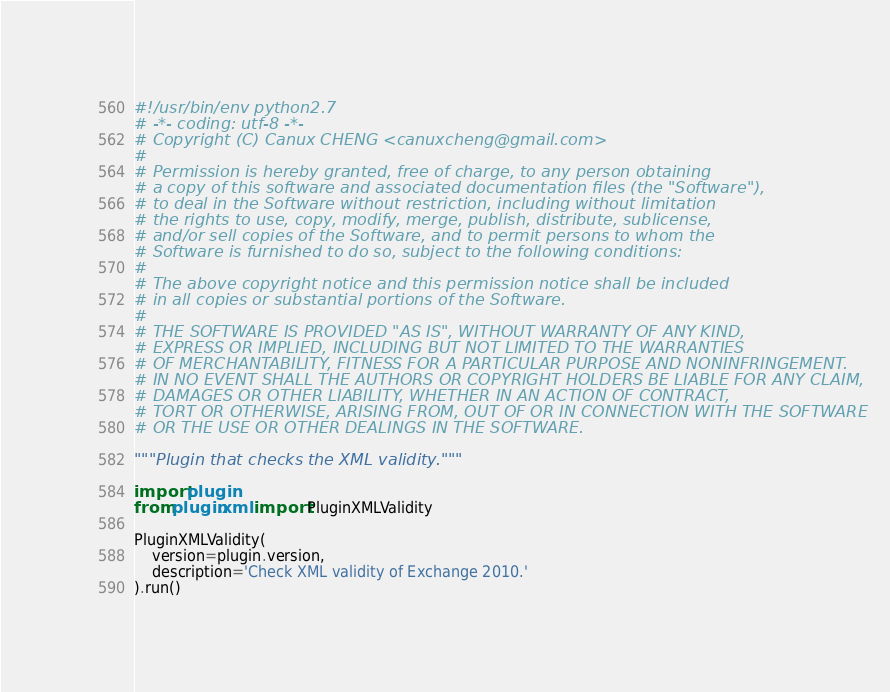Convert code to text. <code><loc_0><loc_0><loc_500><loc_500><_Python_>#!/usr/bin/env python2.7
# -*- coding: utf-8 -*-
# Copyright (C) Canux CHENG <canuxcheng@gmail.com>
#
# Permission is hereby granted, free of charge, to any person obtaining
# a copy of this software and associated documentation files (the "Software"),
# to deal in the Software without restriction, including without limitation
# the rights to use, copy, modify, merge, publish, distribute, sublicense,
# and/or sell copies of the Software, and to permit persons to whom the
# Software is furnished to do so, subject to the following conditions:
#
# The above copyright notice and this permission notice shall be included
# in all copies or substantial portions of the Software.
#
# THE SOFTWARE IS PROVIDED "AS IS", WITHOUT WARRANTY OF ANY KIND,
# EXPRESS OR IMPLIED, INCLUDING BUT NOT LIMITED TO THE WARRANTIES
# OF MERCHANTABILITY, FITNESS FOR A PARTICULAR PURPOSE AND NONINFRINGEMENT.
# IN NO EVENT SHALL THE AUTHORS OR COPYRIGHT HOLDERS BE LIABLE FOR ANY CLAIM,
# DAMAGES OR OTHER LIABILITY, WHETHER IN AN ACTION OF CONTRACT,
# TORT OR OTHERWISE, ARISING FROM, OUT OF OR IN CONNECTION WITH THE SOFTWARE
# OR THE USE OR OTHER DEALINGS IN THE SOFTWARE.

"""Plugin that checks the XML validity."""

import plugin
from plugin.xml import PluginXMLValidity

PluginXMLValidity(
    version=plugin.version,
    description='Check XML validity of Exchange 2010.'
).run()
</code> 